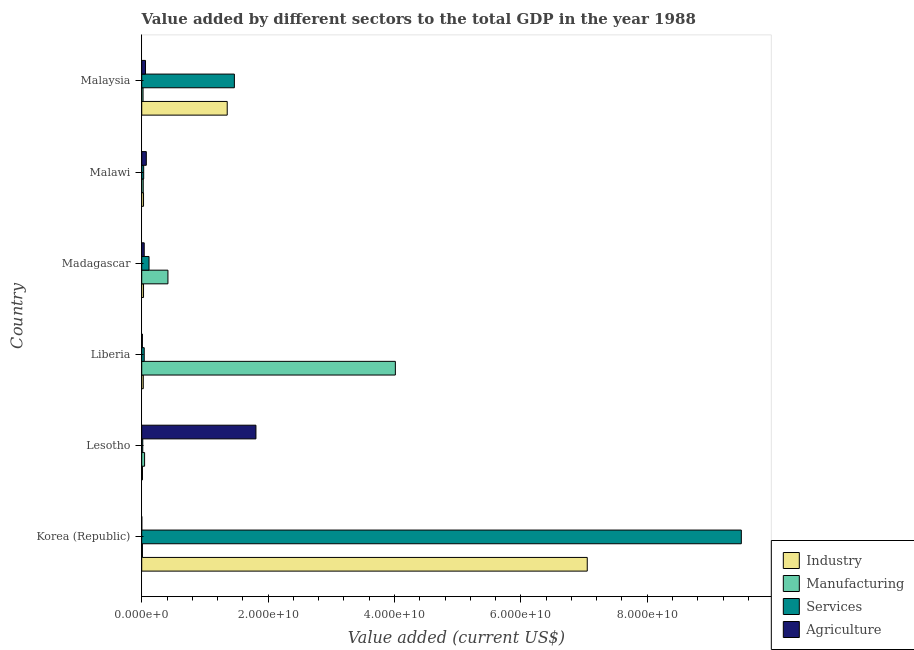Are the number of bars on each tick of the Y-axis equal?
Provide a short and direct response. Yes. How many bars are there on the 4th tick from the top?
Your answer should be compact. 4. How many bars are there on the 6th tick from the bottom?
Provide a short and direct response. 4. What is the label of the 6th group of bars from the top?
Provide a short and direct response. Korea (Republic). In how many cases, is the number of bars for a given country not equal to the number of legend labels?
Make the answer very short. 0. What is the value added by services sector in Lesotho?
Provide a succinct answer. 1.64e+08. Across all countries, what is the maximum value added by industrial sector?
Make the answer very short. 7.05e+1. Across all countries, what is the minimum value added by manufacturing sector?
Ensure brevity in your answer.  1.13e+08. In which country was the value added by manufacturing sector maximum?
Offer a terse response. Liberia. In which country was the value added by industrial sector minimum?
Give a very brief answer. Lesotho. What is the total value added by services sector in the graph?
Provide a short and direct response. 1.12e+11. What is the difference between the value added by industrial sector in Malawi and that in Malaysia?
Give a very brief answer. -1.32e+1. What is the difference between the value added by manufacturing sector in Korea (Republic) and the value added by services sector in Lesotho?
Your response must be concise. -5.12e+07. What is the average value added by services sector per country?
Give a very brief answer. 1.86e+1. What is the difference between the value added by agricultural sector and value added by industrial sector in Malaysia?
Your answer should be very brief. -1.29e+1. In how many countries, is the value added by industrial sector greater than 92000000000 US$?
Offer a terse response. 0. What is the ratio of the value added by manufacturing sector in Liberia to that in Malaysia?
Offer a terse response. 191.82. Is the value added by manufacturing sector in Madagascar less than that in Malaysia?
Your response must be concise. No. What is the difference between the highest and the second highest value added by services sector?
Your answer should be very brief. 8.02e+1. What is the difference between the highest and the lowest value added by services sector?
Your response must be concise. 9.47e+1. Is it the case that in every country, the sum of the value added by agricultural sector and value added by manufacturing sector is greater than the sum of value added by services sector and value added by industrial sector?
Your answer should be very brief. No. What does the 3rd bar from the top in Liberia represents?
Keep it short and to the point. Manufacturing. What does the 4th bar from the bottom in Malaysia represents?
Provide a succinct answer. Agriculture. Are all the bars in the graph horizontal?
Provide a succinct answer. Yes. Are the values on the major ticks of X-axis written in scientific E-notation?
Offer a very short reply. Yes. Does the graph contain any zero values?
Offer a very short reply. No. What is the title of the graph?
Your response must be concise. Value added by different sectors to the total GDP in the year 1988. Does "Primary education" appear as one of the legend labels in the graph?
Keep it short and to the point. No. What is the label or title of the X-axis?
Ensure brevity in your answer.  Value added (current US$). What is the Value added (current US$) in Industry in Korea (Republic)?
Give a very brief answer. 7.05e+1. What is the Value added (current US$) in Manufacturing in Korea (Republic)?
Ensure brevity in your answer.  1.13e+08. What is the Value added (current US$) in Services in Korea (Republic)?
Make the answer very short. 9.49e+1. What is the Value added (current US$) in Agriculture in Korea (Republic)?
Your response must be concise. 9.03e+06. What is the Value added (current US$) in Industry in Lesotho?
Offer a terse response. 1.19e+08. What is the Value added (current US$) of Manufacturing in Lesotho?
Provide a short and direct response. 4.55e+08. What is the Value added (current US$) in Services in Lesotho?
Give a very brief answer. 1.64e+08. What is the Value added (current US$) in Agriculture in Lesotho?
Keep it short and to the point. 1.81e+1. What is the Value added (current US$) in Industry in Liberia?
Keep it short and to the point. 2.48e+08. What is the Value added (current US$) in Manufacturing in Liberia?
Ensure brevity in your answer.  4.01e+1. What is the Value added (current US$) of Services in Liberia?
Your response must be concise. 3.95e+08. What is the Value added (current US$) in Agriculture in Liberia?
Offer a very short reply. 1.05e+08. What is the Value added (current US$) in Industry in Madagascar?
Keep it short and to the point. 2.85e+08. What is the Value added (current US$) of Manufacturing in Madagascar?
Your answer should be compact. 4.15e+09. What is the Value added (current US$) in Services in Madagascar?
Ensure brevity in your answer.  1.16e+09. What is the Value added (current US$) of Agriculture in Madagascar?
Make the answer very short. 3.96e+08. What is the Value added (current US$) in Industry in Malawi?
Ensure brevity in your answer.  2.87e+08. What is the Value added (current US$) of Manufacturing in Malawi?
Offer a very short reply. 2.40e+08. What is the Value added (current US$) of Services in Malawi?
Give a very brief answer. 3.12e+08. What is the Value added (current US$) in Agriculture in Malawi?
Your response must be concise. 7.25e+08. What is the Value added (current US$) of Industry in Malaysia?
Your response must be concise. 1.35e+1. What is the Value added (current US$) in Manufacturing in Malaysia?
Offer a terse response. 2.09e+08. What is the Value added (current US$) in Services in Malaysia?
Your response must be concise. 1.47e+1. What is the Value added (current US$) of Agriculture in Malaysia?
Make the answer very short. 5.99e+08. Across all countries, what is the maximum Value added (current US$) in Industry?
Provide a succinct answer. 7.05e+1. Across all countries, what is the maximum Value added (current US$) of Manufacturing?
Your response must be concise. 4.01e+1. Across all countries, what is the maximum Value added (current US$) in Services?
Offer a terse response. 9.49e+1. Across all countries, what is the maximum Value added (current US$) in Agriculture?
Your answer should be very brief. 1.81e+1. Across all countries, what is the minimum Value added (current US$) in Industry?
Make the answer very short. 1.19e+08. Across all countries, what is the minimum Value added (current US$) in Manufacturing?
Keep it short and to the point. 1.13e+08. Across all countries, what is the minimum Value added (current US$) in Services?
Provide a short and direct response. 1.64e+08. Across all countries, what is the minimum Value added (current US$) in Agriculture?
Offer a very short reply. 9.03e+06. What is the total Value added (current US$) of Industry in the graph?
Ensure brevity in your answer.  8.50e+1. What is the total Value added (current US$) of Manufacturing in the graph?
Your answer should be very brief. 4.53e+1. What is the total Value added (current US$) in Services in the graph?
Ensure brevity in your answer.  1.12e+11. What is the total Value added (current US$) of Agriculture in the graph?
Make the answer very short. 1.99e+1. What is the difference between the Value added (current US$) in Industry in Korea (Republic) and that in Lesotho?
Offer a very short reply. 7.04e+1. What is the difference between the Value added (current US$) in Manufacturing in Korea (Republic) and that in Lesotho?
Make the answer very short. -3.42e+08. What is the difference between the Value added (current US$) of Services in Korea (Republic) and that in Lesotho?
Ensure brevity in your answer.  9.47e+1. What is the difference between the Value added (current US$) in Agriculture in Korea (Republic) and that in Lesotho?
Keep it short and to the point. -1.81e+1. What is the difference between the Value added (current US$) of Industry in Korea (Republic) and that in Liberia?
Give a very brief answer. 7.03e+1. What is the difference between the Value added (current US$) of Manufacturing in Korea (Republic) and that in Liberia?
Offer a terse response. -4.00e+1. What is the difference between the Value added (current US$) in Services in Korea (Republic) and that in Liberia?
Give a very brief answer. 9.45e+1. What is the difference between the Value added (current US$) of Agriculture in Korea (Republic) and that in Liberia?
Make the answer very short. -9.55e+07. What is the difference between the Value added (current US$) of Industry in Korea (Republic) and that in Madagascar?
Provide a short and direct response. 7.02e+1. What is the difference between the Value added (current US$) of Manufacturing in Korea (Republic) and that in Madagascar?
Keep it short and to the point. -4.04e+09. What is the difference between the Value added (current US$) of Services in Korea (Republic) and that in Madagascar?
Offer a very short reply. 9.37e+1. What is the difference between the Value added (current US$) of Agriculture in Korea (Republic) and that in Madagascar?
Provide a succinct answer. -3.87e+08. What is the difference between the Value added (current US$) in Industry in Korea (Republic) and that in Malawi?
Provide a succinct answer. 7.02e+1. What is the difference between the Value added (current US$) in Manufacturing in Korea (Republic) and that in Malawi?
Give a very brief answer. -1.28e+08. What is the difference between the Value added (current US$) of Services in Korea (Republic) and that in Malawi?
Make the answer very short. 9.46e+1. What is the difference between the Value added (current US$) of Agriculture in Korea (Republic) and that in Malawi?
Make the answer very short. -7.16e+08. What is the difference between the Value added (current US$) of Industry in Korea (Republic) and that in Malaysia?
Your answer should be very brief. 5.70e+1. What is the difference between the Value added (current US$) in Manufacturing in Korea (Republic) and that in Malaysia?
Provide a short and direct response. -9.65e+07. What is the difference between the Value added (current US$) of Services in Korea (Republic) and that in Malaysia?
Ensure brevity in your answer.  8.02e+1. What is the difference between the Value added (current US$) in Agriculture in Korea (Republic) and that in Malaysia?
Offer a terse response. -5.90e+08. What is the difference between the Value added (current US$) of Industry in Lesotho and that in Liberia?
Provide a short and direct response. -1.29e+08. What is the difference between the Value added (current US$) in Manufacturing in Lesotho and that in Liberia?
Keep it short and to the point. -3.97e+1. What is the difference between the Value added (current US$) of Services in Lesotho and that in Liberia?
Your answer should be compact. -2.31e+08. What is the difference between the Value added (current US$) in Agriculture in Lesotho and that in Liberia?
Your response must be concise. 1.80e+1. What is the difference between the Value added (current US$) in Industry in Lesotho and that in Madagascar?
Your answer should be very brief. -1.66e+08. What is the difference between the Value added (current US$) in Manufacturing in Lesotho and that in Madagascar?
Your answer should be compact. -3.69e+09. What is the difference between the Value added (current US$) in Services in Lesotho and that in Madagascar?
Offer a terse response. -9.92e+08. What is the difference between the Value added (current US$) in Agriculture in Lesotho and that in Madagascar?
Ensure brevity in your answer.  1.77e+1. What is the difference between the Value added (current US$) of Industry in Lesotho and that in Malawi?
Your answer should be compact. -1.68e+08. What is the difference between the Value added (current US$) of Manufacturing in Lesotho and that in Malawi?
Give a very brief answer. 2.15e+08. What is the difference between the Value added (current US$) of Services in Lesotho and that in Malawi?
Provide a short and direct response. -1.48e+08. What is the difference between the Value added (current US$) in Agriculture in Lesotho and that in Malawi?
Make the answer very short. 1.73e+1. What is the difference between the Value added (current US$) in Industry in Lesotho and that in Malaysia?
Give a very brief answer. -1.34e+1. What is the difference between the Value added (current US$) in Manufacturing in Lesotho and that in Malaysia?
Offer a terse response. 2.46e+08. What is the difference between the Value added (current US$) in Services in Lesotho and that in Malaysia?
Provide a short and direct response. -1.45e+1. What is the difference between the Value added (current US$) of Agriculture in Lesotho and that in Malaysia?
Offer a very short reply. 1.75e+1. What is the difference between the Value added (current US$) of Industry in Liberia and that in Madagascar?
Ensure brevity in your answer.  -3.73e+07. What is the difference between the Value added (current US$) of Manufacturing in Liberia and that in Madagascar?
Ensure brevity in your answer.  3.60e+1. What is the difference between the Value added (current US$) in Services in Liberia and that in Madagascar?
Ensure brevity in your answer.  -7.61e+08. What is the difference between the Value added (current US$) in Agriculture in Liberia and that in Madagascar?
Your answer should be very brief. -2.91e+08. What is the difference between the Value added (current US$) in Industry in Liberia and that in Malawi?
Provide a short and direct response. -3.94e+07. What is the difference between the Value added (current US$) of Manufacturing in Liberia and that in Malawi?
Offer a very short reply. 3.99e+1. What is the difference between the Value added (current US$) of Services in Liberia and that in Malawi?
Your answer should be very brief. 8.33e+07. What is the difference between the Value added (current US$) in Agriculture in Liberia and that in Malawi?
Keep it short and to the point. -6.21e+08. What is the difference between the Value added (current US$) in Industry in Liberia and that in Malaysia?
Your answer should be very brief. -1.33e+1. What is the difference between the Value added (current US$) in Manufacturing in Liberia and that in Malaysia?
Ensure brevity in your answer.  3.99e+1. What is the difference between the Value added (current US$) in Services in Liberia and that in Malaysia?
Make the answer very short. -1.43e+1. What is the difference between the Value added (current US$) of Agriculture in Liberia and that in Malaysia?
Provide a succinct answer. -4.95e+08. What is the difference between the Value added (current US$) of Industry in Madagascar and that in Malawi?
Provide a succinct answer. -2.07e+06. What is the difference between the Value added (current US$) in Manufacturing in Madagascar and that in Malawi?
Provide a short and direct response. 3.91e+09. What is the difference between the Value added (current US$) in Services in Madagascar and that in Malawi?
Provide a short and direct response. 8.44e+08. What is the difference between the Value added (current US$) in Agriculture in Madagascar and that in Malawi?
Make the answer very short. -3.30e+08. What is the difference between the Value added (current US$) of Industry in Madagascar and that in Malaysia?
Your answer should be compact. -1.32e+1. What is the difference between the Value added (current US$) of Manufacturing in Madagascar and that in Malaysia?
Give a very brief answer. 3.94e+09. What is the difference between the Value added (current US$) of Services in Madagascar and that in Malaysia?
Your response must be concise. -1.35e+1. What is the difference between the Value added (current US$) in Agriculture in Madagascar and that in Malaysia?
Keep it short and to the point. -2.04e+08. What is the difference between the Value added (current US$) in Industry in Malawi and that in Malaysia?
Make the answer very short. -1.32e+1. What is the difference between the Value added (current US$) in Manufacturing in Malawi and that in Malaysia?
Keep it short and to the point. 3.12e+07. What is the difference between the Value added (current US$) of Services in Malawi and that in Malaysia?
Provide a short and direct response. -1.44e+1. What is the difference between the Value added (current US$) of Agriculture in Malawi and that in Malaysia?
Your answer should be compact. 1.26e+08. What is the difference between the Value added (current US$) in Industry in Korea (Republic) and the Value added (current US$) in Manufacturing in Lesotho?
Make the answer very short. 7.00e+1. What is the difference between the Value added (current US$) of Industry in Korea (Republic) and the Value added (current US$) of Services in Lesotho?
Offer a terse response. 7.03e+1. What is the difference between the Value added (current US$) of Industry in Korea (Republic) and the Value added (current US$) of Agriculture in Lesotho?
Give a very brief answer. 5.24e+1. What is the difference between the Value added (current US$) in Manufacturing in Korea (Republic) and the Value added (current US$) in Services in Lesotho?
Give a very brief answer. -5.12e+07. What is the difference between the Value added (current US$) in Manufacturing in Korea (Republic) and the Value added (current US$) in Agriculture in Lesotho?
Offer a very short reply. -1.80e+1. What is the difference between the Value added (current US$) in Services in Korea (Republic) and the Value added (current US$) in Agriculture in Lesotho?
Ensure brevity in your answer.  7.68e+1. What is the difference between the Value added (current US$) in Industry in Korea (Republic) and the Value added (current US$) in Manufacturing in Liberia?
Your response must be concise. 3.04e+1. What is the difference between the Value added (current US$) in Industry in Korea (Republic) and the Value added (current US$) in Services in Liberia?
Ensure brevity in your answer.  7.01e+1. What is the difference between the Value added (current US$) in Industry in Korea (Republic) and the Value added (current US$) in Agriculture in Liberia?
Offer a very short reply. 7.04e+1. What is the difference between the Value added (current US$) of Manufacturing in Korea (Republic) and the Value added (current US$) of Services in Liberia?
Make the answer very short. -2.82e+08. What is the difference between the Value added (current US$) of Manufacturing in Korea (Republic) and the Value added (current US$) of Agriculture in Liberia?
Give a very brief answer. 8.20e+06. What is the difference between the Value added (current US$) of Services in Korea (Republic) and the Value added (current US$) of Agriculture in Liberia?
Keep it short and to the point. 9.48e+1. What is the difference between the Value added (current US$) in Industry in Korea (Republic) and the Value added (current US$) in Manufacturing in Madagascar?
Your response must be concise. 6.64e+1. What is the difference between the Value added (current US$) in Industry in Korea (Republic) and the Value added (current US$) in Services in Madagascar?
Your response must be concise. 6.93e+1. What is the difference between the Value added (current US$) in Industry in Korea (Republic) and the Value added (current US$) in Agriculture in Madagascar?
Your answer should be compact. 7.01e+1. What is the difference between the Value added (current US$) of Manufacturing in Korea (Republic) and the Value added (current US$) of Services in Madagascar?
Provide a short and direct response. -1.04e+09. What is the difference between the Value added (current US$) of Manufacturing in Korea (Republic) and the Value added (current US$) of Agriculture in Madagascar?
Your answer should be compact. -2.83e+08. What is the difference between the Value added (current US$) of Services in Korea (Republic) and the Value added (current US$) of Agriculture in Madagascar?
Your answer should be compact. 9.45e+1. What is the difference between the Value added (current US$) of Industry in Korea (Republic) and the Value added (current US$) of Manufacturing in Malawi?
Make the answer very short. 7.03e+1. What is the difference between the Value added (current US$) of Industry in Korea (Republic) and the Value added (current US$) of Services in Malawi?
Offer a very short reply. 7.02e+1. What is the difference between the Value added (current US$) in Industry in Korea (Republic) and the Value added (current US$) in Agriculture in Malawi?
Your answer should be very brief. 6.98e+1. What is the difference between the Value added (current US$) in Manufacturing in Korea (Republic) and the Value added (current US$) in Services in Malawi?
Offer a very short reply. -1.99e+08. What is the difference between the Value added (current US$) in Manufacturing in Korea (Republic) and the Value added (current US$) in Agriculture in Malawi?
Make the answer very short. -6.13e+08. What is the difference between the Value added (current US$) of Services in Korea (Republic) and the Value added (current US$) of Agriculture in Malawi?
Provide a succinct answer. 9.42e+1. What is the difference between the Value added (current US$) in Industry in Korea (Republic) and the Value added (current US$) in Manufacturing in Malaysia?
Your answer should be compact. 7.03e+1. What is the difference between the Value added (current US$) in Industry in Korea (Republic) and the Value added (current US$) in Services in Malaysia?
Your response must be concise. 5.58e+1. What is the difference between the Value added (current US$) in Industry in Korea (Republic) and the Value added (current US$) in Agriculture in Malaysia?
Offer a terse response. 6.99e+1. What is the difference between the Value added (current US$) of Manufacturing in Korea (Republic) and the Value added (current US$) of Services in Malaysia?
Your answer should be very brief. -1.46e+1. What is the difference between the Value added (current US$) in Manufacturing in Korea (Republic) and the Value added (current US$) in Agriculture in Malaysia?
Provide a succinct answer. -4.87e+08. What is the difference between the Value added (current US$) of Services in Korea (Republic) and the Value added (current US$) of Agriculture in Malaysia?
Provide a short and direct response. 9.43e+1. What is the difference between the Value added (current US$) in Industry in Lesotho and the Value added (current US$) in Manufacturing in Liberia?
Provide a short and direct response. -4.00e+1. What is the difference between the Value added (current US$) of Industry in Lesotho and the Value added (current US$) of Services in Liberia?
Your answer should be compact. -2.76e+08. What is the difference between the Value added (current US$) in Industry in Lesotho and the Value added (current US$) in Agriculture in Liberia?
Your answer should be very brief. 1.44e+07. What is the difference between the Value added (current US$) in Manufacturing in Lesotho and the Value added (current US$) in Services in Liberia?
Your response must be concise. 6.04e+07. What is the difference between the Value added (current US$) of Manufacturing in Lesotho and the Value added (current US$) of Agriculture in Liberia?
Provide a short and direct response. 3.51e+08. What is the difference between the Value added (current US$) of Services in Lesotho and the Value added (current US$) of Agriculture in Liberia?
Your response must be concise. 5.95e+07. What is the difference between the Value added (current US$) of Industry in Lesotho and the Value added (current US$) of Manufacturing in Madagascar?
Your response must be concise. -4.03e+09. What is the difference between the Value added (current US$) in Industry in Lesotho and the Value added (current US$) in Services in Madagascar?
Keep it short and to the point. -1.04e+09. What is the difference between the Value added (current US$) in Industry in Lesotho and the Value added (current US$) in Agriculture in Madagascar?
Your answer should be compact. -2.77e+08. What is the difference between the Value added (current US$) in Manufacturing in Lesotho and the Value added (current US$) in Services in Madagascar?
Make the answer very short. -7.00e+08. What is the difference between the Value added (current US$) of Manufacturing in Lesotho and the Value added (current US$) of Agriculture in Madagascar?
Your answer should be compact. 5.95e+07. What is the difference between the Value added (current US$) in Services in Lesotho and the Value added (current US$) in Agriculture in Madagascar?
Provide a short and direct response. -2.32e+08. What is the difference between the Value added (current US$) of Industry in Lesotho and the Value added (current US$) of Manufacturing in Malawi?
Your answer should be compact. -1.22e+08. What is the difference between the Value added (current US$) in Industry in Lesotho and the Value added (current US$) in Services in Malawi?
Ensure brevity in your answer.  -1.93e+08. What is the difference between the Value added (current US$) in Industry in Lesotho and the Value added (current US$) in Agriculture in Malawi?
Give a very brief answer. -6.06e+08. What is the difference between the Value added (current US$) in Manufacturing in Lesotho and the Value added (current US$) in Services in Malawi?
Offer a very short reply. 1.44e+08. What is the difference between the Value added (current US$) of Manufacturing in Lesotho and the Value added (current US$) of Agriculture in Malawi?
Keep it short and to the point. -2.70e+08. What is the difference between the Value added (current US$) in Services in Lesotho and the Value added (current US$) in Agriculture in Malawi?
Your answer should be very brief. -5.61e+08. What is the difference between the Value added (current US$) in Industry in Lesotho and the Value added (current US$) in Manufacturing in Malaysia?
Give a very brief answer. -9.04e+07. What is the difference between the Value added (current US$) in Industry in Lesotho and the Value added (current US$) in Services in Malaysia?
Offer a terse response. -1.45e+1. What is the difference between the Value added (current US$) in Industry in Lesotho and the Value added (current US$) in Agriculture in Malaysia?
Offer a very short reply. -4.80e+08. What is the difference between the Value added (current US$) in Manufacturing in Lesotho and the Value added (current US$) in Services in Malaysia?
Your answer should be compact. -1.42e+1. What is the difference between the Value added (current US$) of Manufacturing in Lesotho and the Value added (current US$) of Agriculture in Malaysia?
Provide a short and direct response. -1.44e+08. What is the difference between the Value added (current US$) in Services in Lesotho and the Value added (current US$) in Agriculture in Malaysia?
Your answer should be compact. -4.35e+08. What is the difference between the Value added (current US$) in Industry in Liberia and the Value added (current US$) in Manufacturing in Madagascar?
Ensure brevity in your answer.  -3.90e+09. What is the difference between the Value added (current US$) in Industry in Liberia and the Value added (current US$) in Services in Madagascar?
Offer a terse response. -9.08e+08. What is the difference between the Value added (current US$) in Industry in Liberia and the Value added (current US$) in Agriculture in Madagascar?
Your answer should be very brief. -1.48e+08. What is the difference between the Value added (current US$) of Manufacturing in Liberia and the Value added (current US$) of Services in Madagascar?
Your response must be concise. 3.90e+1. What is the difference between the Value added (current US$) of Manufacturing in Liberia and the Value added (current US$) of Agriculture in Madagascar?
Offer a very short reply. 3.97e+1. What is the difference between the Value added (current US$) in Services in Liberia and the Value added (current US$) in Agriculture in Madagascar?
Make the answer very short. -9.00e+05. What is the difference between the Value added (current US$) in Industry in Liberia and the Value added (current US$) in Manufacturing in Malawi?
Ensure brevity in your answer.  7.39e+06. What is the difference between the Value added (current US$) of Industry in Liberia and the Value added (current US$) of Services in Malawi?
Provide a succinct answer. -6.37e+07. What is the difference between the Value added (current US$) of Industry in Liberia and the Value added (current US$) of Agriculture in Malawi?
Your answer should be compact. -4.78e+08. What is the difference between the Value added (current US$) of Manufacturing in Liberia and the Value added (current US$) of Services in Malawi?
Your answer should be compact. 3.98e+1. What is the difference between the Value added (current US$) in Manufacturing in Liberia and the Value added (current US$) in Agriculture in Malawi?
Ensure brevity in your answer.  3.94e+1. What is the difference between the Value added (current US$) of Services in Liberia and the Value added (current US$) of Agriculture in Malawi?
Keep it short and to the point. -3.31e+08. What is the difference between the Value added (current US$) in Industry in Liberia and the Value added (current US$) in Manufacturing in Malaysia?
Make the answer very short. 3.86e+07. What is the difference between the Value added (current US$) in Industry in Liberia and the Value added (current US$) in Services in Malaysia?
Make the answer very short. -1.44e+1. What is the difference between the Value added (current US$) in Industry in Liberia and the Value added (current US$) in Agriculture in Malaysia?
Your answer should be compact. -3.51e+08. What is the difference between the Value added (current US$) in Manufacturing in Liberia and the Value added (current US$) in Services in Malaysia?
Give a very brief answer. 2.55e+1. What is the difference between the Value added (current US$) in Manufacturing in Liberia and the Value added (current US$) in Agriculture in Malaysia?
Give a very brief answer. 3.95e+1. What is the difference between the Value added (current US$) of Services in Liberia and the Value added (current US$) of Agriculture in Malaysia?
Your response must be concise. -2.04e+08. What is the difference between the Value added (current US$) in Industry in Madagascar and the Value added (current US$) in Manufacturing in Malawi?
Ensure brevity in your answer.  4.47e+07. What is the difference between the Value added (current US$) of Industry in Madagascar and the Value added (current US$) of Services in Malawi?
Make the answer very short. -2.64e+07. What is the difference between the Value added (current US$) of Industry in Madagascar and the Value added (current US$) of Agriculture in Malawi?
Provide a short and direct response. -4.40e+08. What is the difference between the Value added (current US$) of Manufacturing in Madagascar and the Value added (current US$) of Services in Malawi?
Make the answer very short. 3.84e+09. What is the difference between the Value added (current US$) of Manufacturing in Madagascar and the Value added (current US$) of Agriculture in Malawi?
Your answer should be very brief. 3.42e+09. What is the difference between the Value added (current US$) of Services in Madagascar and the Value added (current US$) of Agriculture in Malawi?
Give a very brief answer. 4.30e+08. What is the difference between the Value added (current US$) of Industry in Madagascar and the Value added (current US$) of Manufacturing in Malaysia?
Ensure brevity in your answer.  7.59e+07. What is the difference between the Value added (current US$) in Industry in Madagascar and the Value added (current US$) in Services in Malaysia?
Provide a short and direct response. -1.44e+1. What is the difference between the Value added (current US$) of Industry in Madagascar and the Value added (current US$) of Agriculture in Malaysia?
Your response must be concise. -3.14e+08. What is the difference between the Value added (current US$) of Manufacturing in Madagascar and the Value added (current US$) of Services in Malaysia?
Make the answer very short. -1.05e+1. What is the difference between the Value added (current US$) in Manufacturing in Madagascar and the Value added (current US$) in Agriculture in Malaysia?
Your answer should be compact. 3.55e+09. What is the difference between the Value added (current US$) in Services in Madagascar and the Value added (current US$) in Agriculture in Malaysia?
Your response must be concise. 5.56e+08. What is the difference between the Value added (current US$) of Industry in Malawi and the Value added (current US$) of Manufacturing in Malaysia?
Offer a terse response. 7.79e+07. What is the difference between the Value added (current US$) of Industry in Malawi and the Value added (current US$) of Services in Malaysia?
Your response must be concise. -1.44e+1. What is the difference between the Value added (current US$) in Industry in Malawi and the Value added (current US$) in Agriculture in Malaysia?
Your answer should be very brief. -3.12e+08. What is the difference between the Value added (current US$) of Manufacturing in Malawi and the Value added (current US$) of Services in Malaysia?
Offer a very short reply. -1.44e+1. What is the difference between the Value added (current US$) in Manufacturing in Malawi and the Value added (current US$) in Agriculture in Malaysia?
Provide a short and direct response. -3.59e+08. What is the difference between the Value added (current US$) of Services in Malawi and the Value added (current US$) of Agriculture in Malaysia?
Make the answer very short. -2.88e+08. What is the average Value added (current US$) of Industry per country?
Keep it short and to the point. 1.42e+1. What is the average Value added (current US$) in Manufacturing per country?
Keep it short and to the point. 7.55e+09. What is the average Value added (current US$) of Services per country?
Your answer should be very brief. 1.86e+1. What is the average Value added (current US$) of Agriculture per country?
Your response must be concise. 3.32e+09. What is the difference between the Value added (current US$) of Industry and Value added (current US$) of Manufacturing in Korea (Republic)?
Ensure brevity in your answer.  7.04e+1. What is the difference between the Value added (current US$) of Industry and Value added (current US$) of Services in Korea (Republic)?
Offer a terse response. -2.44e+1. What is the difference between the Value added (current US$) of Industry and Value added (current US$) of Agriculture in Korea (Republic)?
Provide a short and direct response. 7.05e+1. What is the difference between the Value added (current US$) in Manufacturing and Value added (current US$) in Services in Korea (Republic)?
Offer a very short reply. -9.48e+1. What is the difference between the Value added (current US$) in Manufacturing and Value added (current US$) in Agriculture in Korea (Republic)?
Provide a short and direct response. 1.04e+08. What is the difference between the Value added (current US$) of Services and Value added (current US$) of Agriculture in Korea (Republic)?
Your answer should be compact. 9.49e+1. What is the difference between the Value added (current US$) in Industry and Value added (current US$) in Manufacturing in Lesotho?
Ensure brevity in your answer.  -3.36e+08. What is the difference between the Value added (current US$) of Industry and Value added (current US$) of Services in Lesotho?
Give a very brief answer. -4.51e+07. What is the difference between the Value added (current US$) in Industry and Value added (current US$) in Agriculture in Lesotho?
Your answer should be compact. -1.80e+1. What is the difference between the Value added (current US$) of Manufacturing and Value added (current US$) of Services in Lesotho?
Provide a short and direct response. 2.91e+08. What is the difference between the Value added (current US$) in Manufacturing and Value added (current US$) in Agriculture in Lesotho?
Offer a terse response. -1.76e+1. What is the difference between the Value added (current US$) of Services and Value added (current US$) of Agriculture in Lesotho?
Keep it short and to the point. -1.79e+1. What is the difference between the Value added (current US$) in Industry and Value added (current US$) in Manufacturing in Liberia?
Your answer should be compact. -3.99e+1. What is the difference between the Value added (current US$) of Industry and Value added (current US$) of Services in Liberia?
Make the answer very short. -1.47e+08. What is the difference between the Value added (current US$) of Industry and Value added (current US$) of Agriculture in Liberia?
Make the answer very short. 1.43e+08. What is the difference between the Value added (current US$) of Manufacturing and Value added (current US$) of Services in Liberia?
Offer a terse response. 3.97e+1. What is the difference between the Value added (current US$) of Manufacturing and Value added (current US$) of Agriculture in Liberia?
Provide a short and direct response. 4.00e+1. What is the difference between the Value added (current US$) in Services and Value added (current US$) in Agriculture in Liberia?
Your response must be concise. 2.90e+08. What is the difference between the Value added (current US$) in Industry and Value added (current US$) in Manufacturing in Madagascar?
Your answer should be compact. -3.86e+09. What is the difference between the Value added (current US$) of Industry and Value added (current US$) of Services in Madagascar?
Your answer should be compact. -8.70e+08. What is the difference between the Value added (current US$) of Industry and Value added (current US$) of Agriculture in Madagascar?
Your answer should be very brief. -1.11e+08. What is the difference between the Value added (current US$) in Manufacturing and Value added (current US$) in Services in Madagascar?
Provide a short and direct response. 2.99e+09. What is the difference between the Value added (current US$) of Manufacturing and Value added (current US$) of Agriculture in Madagascar?
Your answer should be very brief. 3.75e+09. What is the difference between the Value added (current US$) in Services and Value added (current US$) in Agriculture in Madagascar?
Ensure brevity in your answer.  7.60e+08. What is the difference between the Value added (current US$) in Industry and Value added (current US$) in Manufacturing in Malawi?
Give a very brief answer. 4.68e+07. What is the difference between the Value added (current US$) of Industry and Value added (current US$) of Services in Malawi?
Give a very brief answer. -2.43e+07. What is the difference between the Value added (current US$) in Industry and Value added (current US$) in Agriculture in Malawi?
Provide a succinct answer. -4.38e+08. What is the difference between the Value added (current US$) in Manufacturing and Value added (current US$) in Services in Malawi?
Make the answer very short. -7.11e+07. What is the difference between the Value added (current US$) in Manufacturing and Value added (current US$) in Agriculture in Malawi?
Provide a short and direct response. -4.85e+08. What is the difference between the Value added (current US$) in Services and Value added (current US$) in Agriculture in Malawi?
Make the answer very short. -4.14e+08. What is the difference between the Value added (current US$) in Industry and Value added (current US$) in Manufacturing in Malaysia?
Make the answer very short. 1.33e+1. What is the difference between the Value added (current US$) in Industry and Value added (current US$) in Services in Malaysia?
Offer a terse response. -1.13e+09. What is the difference between the Value added (current US$) in Industry and Value added (current US$) in Agriculture in Malaysia?
Provide a succinct answer. 1.29e+1. What is the difference between the Value added (current US$) of Manufacturing and Value added (current US$) of Services in Malaysia?
Provide a short and direct response. -1.45e+1. What is the difference between the Value added (current US$) of Manufacturing and Value added (current US$) of Agriculture in Malaysia?
Your answer should be compact. -3.90e+08. What is the difference between the Value added (current US$) of Services and Value added (current US$) of Agriculture in Malaysia?
Give a very brief answer. 1.41e+1. What is the ratio of the Value added (current US$) of Industry in Korea (Republic) to that in Lesotho?
Your answer should be very brief. 593. What is the ratio of the Value added (current US$) of Manufacturing in Korea (Republic) to that in Lesotho?
Your response must be concise. 0.25. What is the ratio of the Value added (current US$) of Services in Korea (Republic) to that in Lesotho?
Your response must be concise. 578.71. What is the ratio of the Value added (current US$) in Agriculture in Korea (Republic) to that in Lesotho?
Provide a short and direct response. 0. What is the ratio of the Value added (current US$) in Industry in Korea (Republic) to that in Liberia?
Provide a short and direct response. 284.52. What is the ratio of the Value added (current US$) of Manufacturing in Korea (Republic) to that in Liberia?
Provide a succinct answer. 0. What is the ratio of the Value added (current US$) in Services in Korea (Republic) to that in Liberia?
Offer a very short reply. 240.34. What is the ratio of the Value added (current US$) of Agriculture in Korea (Republic) to that in Liberia?
Your response must be concise. 0.09. What is the ratio of the Value added (current US$) of Industry in Korea (Republic) to that in Madagascar?
Offer a very short reply. 247.27. What is the ratio of the Value added (current US$) in Manufacturing in Korea (Republic) to that in Madagascar?
Your response must be concise. 0.03. What is the ratio of the Value added (current US$) of Services in Korea (Republic) to that in Madagascar?
Make the answer very short. 82.11. What is the ratio of the Value added (current US$) in Agriculture in Korea (Republic) to that in Madagascar?
Provide a short and direct response. 0.02. What is the ratio of the Value added (current US$) in Industry in Korea (Republic) to that in Malawi?
Your answer should be compact. 245.49. What is the ratio of the Value added (current US$) in Manufacturing in Korea (Republic) to that in Malawi?
Make the answer very short. 0.47. What is the ratio of the Value added (current US$) in Services in Korea (Republic) to that in Malawi?
Keep it short and to the point. 304.58. What is the ratio of the Value added (current US$) of Agriculture in Korea (Republic) to that in Malawi?
Ensure brevity in your answer.  0.01. What is the ratio of the Value added (current US$) of Industry in Korea (Republic) to that in Malaysia?
Give a very brief answer. 5.21. What is the ratio of the Value added (current US$) in Manufacturing in Korea (Republic) to that in Malaysia?
Give a very brief answer. 0.54. What is the ratio of the Value added (current US$) in Services in Korea (Republic) to that in Malaysia?
Offer a terse response. 6.47. What is the ratio of the Value added (current US$) in Agriculture in Korea (Republic) to that in Malaysia?
Offer a terse response. 0.02. What is the ratio of the Value added (current US$) of Industry in Lesotho to that in Liberia?
Ensure brevity in your answer.  0.48. What is the ratio of the Value added (current US$) in Manufacturing in Lesotho to that in Liberia?
Your answer should be very brief. 0.01. What is the ratio of the Value added (current US$) in Services in Lesotho to that in Liberia?
Make the answer very short. 0.42. What is the ratio of the Value added (current US$) of Agriculture in Lesotho to that in Liberia?
Keep it short and to the point. 172.94. What is the ratio of the Value added (current US$) in Industry in Lesotho to that in Madagascar?
Offer a terse response. 0.42. What is the ratio of the Value added (current US$) of Manufacturing in Lesotho to that in Madagascar?
Provide a succinct answer. 0.11. What is the ratio of the Value added (current US$) in Services in Lesotho to that in Madagascar?
Keep it short and to the point. 0.14. What is the ratio of the Value added (current US$) in Agriculture in Lesotho to that in Madagascar?
Offer a very short reply. 45.68. What is the ratio of the Value added (current US$) of Industry in Lesotho to that in Malawi?
Provide a succinct answer. 0.41. What is the ratio of the Value added (current US$) of Manufacturing in Lesotho to that in Malawi?
Give a very brief answer. 1.89. What is the ratio of the Value added (current US$) of Services in Lesotho to that in Malawi?
Your answer should be compact. 0.53. What is the ratio of the Value added (current US$) in Agriculture in Lesotho to that in Malawi?
Ensure brevity in your answer.  24.92. What is the ratio of the Value added (current US$) in Industry in Lesotho to that in Malaysia?
Keep it short and to the point. 0.01. What is the ratio of the Value added (current US$) of Manufacturing in Lesotho to that in Malaysia?
Make the answer very short. 2.18. What is the ratio of the Value added (current US$) in Services in Lesotho to that in Malaysia?
Keep it short and to the point. 0.01. What is the ratio of the Value added (current US$) in Agriculture in Lesotho to that in Malaysia?
Your answer should be very brief. 30.16. What is the ratio of the Value added (current US$) of Industry in Liberia to that in Madagascar?
Offer a terse response. 0.87. What is the ratio of the Value added (current US$) of Manufacturing in Liberia to that in Madagascar?
Offer a very short reply. 9.67. What is the ratio of the Value added (current US$) in Services in Liberia to that in Madagascar?
Give a very brief answer. 0.34. What is the ratio of the Value added (current US$) in Agriculture in Liberia to that in Madagascar?
Provide a short and direct response. 0.26. What is the ratio of the Value added (current US$) of Industry in Liberia to that in Malawi?
Keep it short and to the point. 0.86. What is the ratio of the Value added (current US$) of Manufacturing in Liberia to that in Malawi?
Keep it short and to the point. 166.96. What is the ratio of the Value added (current US$) in Services in Liberia to that in Malawi?
Offer a terse response. 1.27. What is the ratio of the Value added (current US$) in Agriculture in Liberia to that in Malawi?
Provide a short and direct response. 0.14. What is the ratio of the Value added (current US$) in Industry in Liberia to that in Malaysia?
Make the answer very short. 0.02. What is the ratio of the Value added (current US$) of Manufacturing in Liberia to that in Malaysia?
Your response must be concise. 191.82. What is the ratio of the Value added (current US$) in Services in Liberia to that in Malaysia?
Your response must be concise. 0.03. What is the ratio of the Value added (current US$) in Agriculture in Liberia to that in Malaysia?
Provide a succinct answer. 0.17. What is the ratio of the Value added (current US$) of Manufacturing in Madagascar to that in Malawi?
Give a very brief answer. 17.26. What is the ratio of the Value added (current US$) in Services in Madagascar to that in Malawi?
Provide a succinct answer. 3.71. What is the ratio of the Value added (current US$) in Agriculture in Madagascar to that in Malawi?
Ensure brevity in your answer.  0.55. What is the ratio of the Value added (current US$) in Industry in Madagascar to that in Malaysia?
Provide a short and direct response. 0.02. What is the ratio of the Value added (current US$) of Manufacturing in Madagascar to that in Malaysia?
Offer a terse response. 19.83. What is the ratio of the Value added (current US$) in Services in Madagascar to that in Malaysia?
Your response must be concise. 0.08. What is the ratio of the Value added (current US$) in Agriculture in Madagascar to that in Malaysia?
Provide a short and direct response. 0.66. What is the ratio of the Value added (current US$) in Industry in Malawi to that in Malaysia?
Offer a very short reply. 0.02. What is the ratio of the Value added (current US$) of Manufacturing in Malawi to that in Malaysia?
Keep it short and to the point. 1.15. What is the ratio of the Value added (current US$) in Services in Malawi to that in Malaysia?
Ensure brevity in your answer.  0.02. What is the ratio of the Value added (current US$) of Agriculture in Malawi to that in Malaysia?
Offer a terse response. 1.21. What is the difference between the highest and the second highest Value added (current US$) in Industry?
Provide a short and direct response. 5.70e+1. What is the difference between the highest and the second highest Value added (current US$) of Manufacturing?
Make the answer very short. 3.60e+1. What is the difference between the highest and the second highest Value added (current US$) in Services?
Give a very brief answer. 8.02e+1. What is the difference between the highest and the second highest Value added (current US$) of Agriculture?
Your answer should be compact. 1.73e+1. What is the difference between the highest and the lowest Value added (current US$) in Industry?
Your answer should be very brief. 7.04e+1. What is the difference between the highest and the lowest Value added (current US$) in Manufacturing?
Provide a succinct answer. 4.00e+1. What is the difference between the highest and the lowest Value added (current US$) of Services?
Ensure brevity in your answer.  9.47e+1. What is the difference between the highest and the lowest Value added (current US$) in Agriculture?
Make the answer very short. 1.81e+1. 